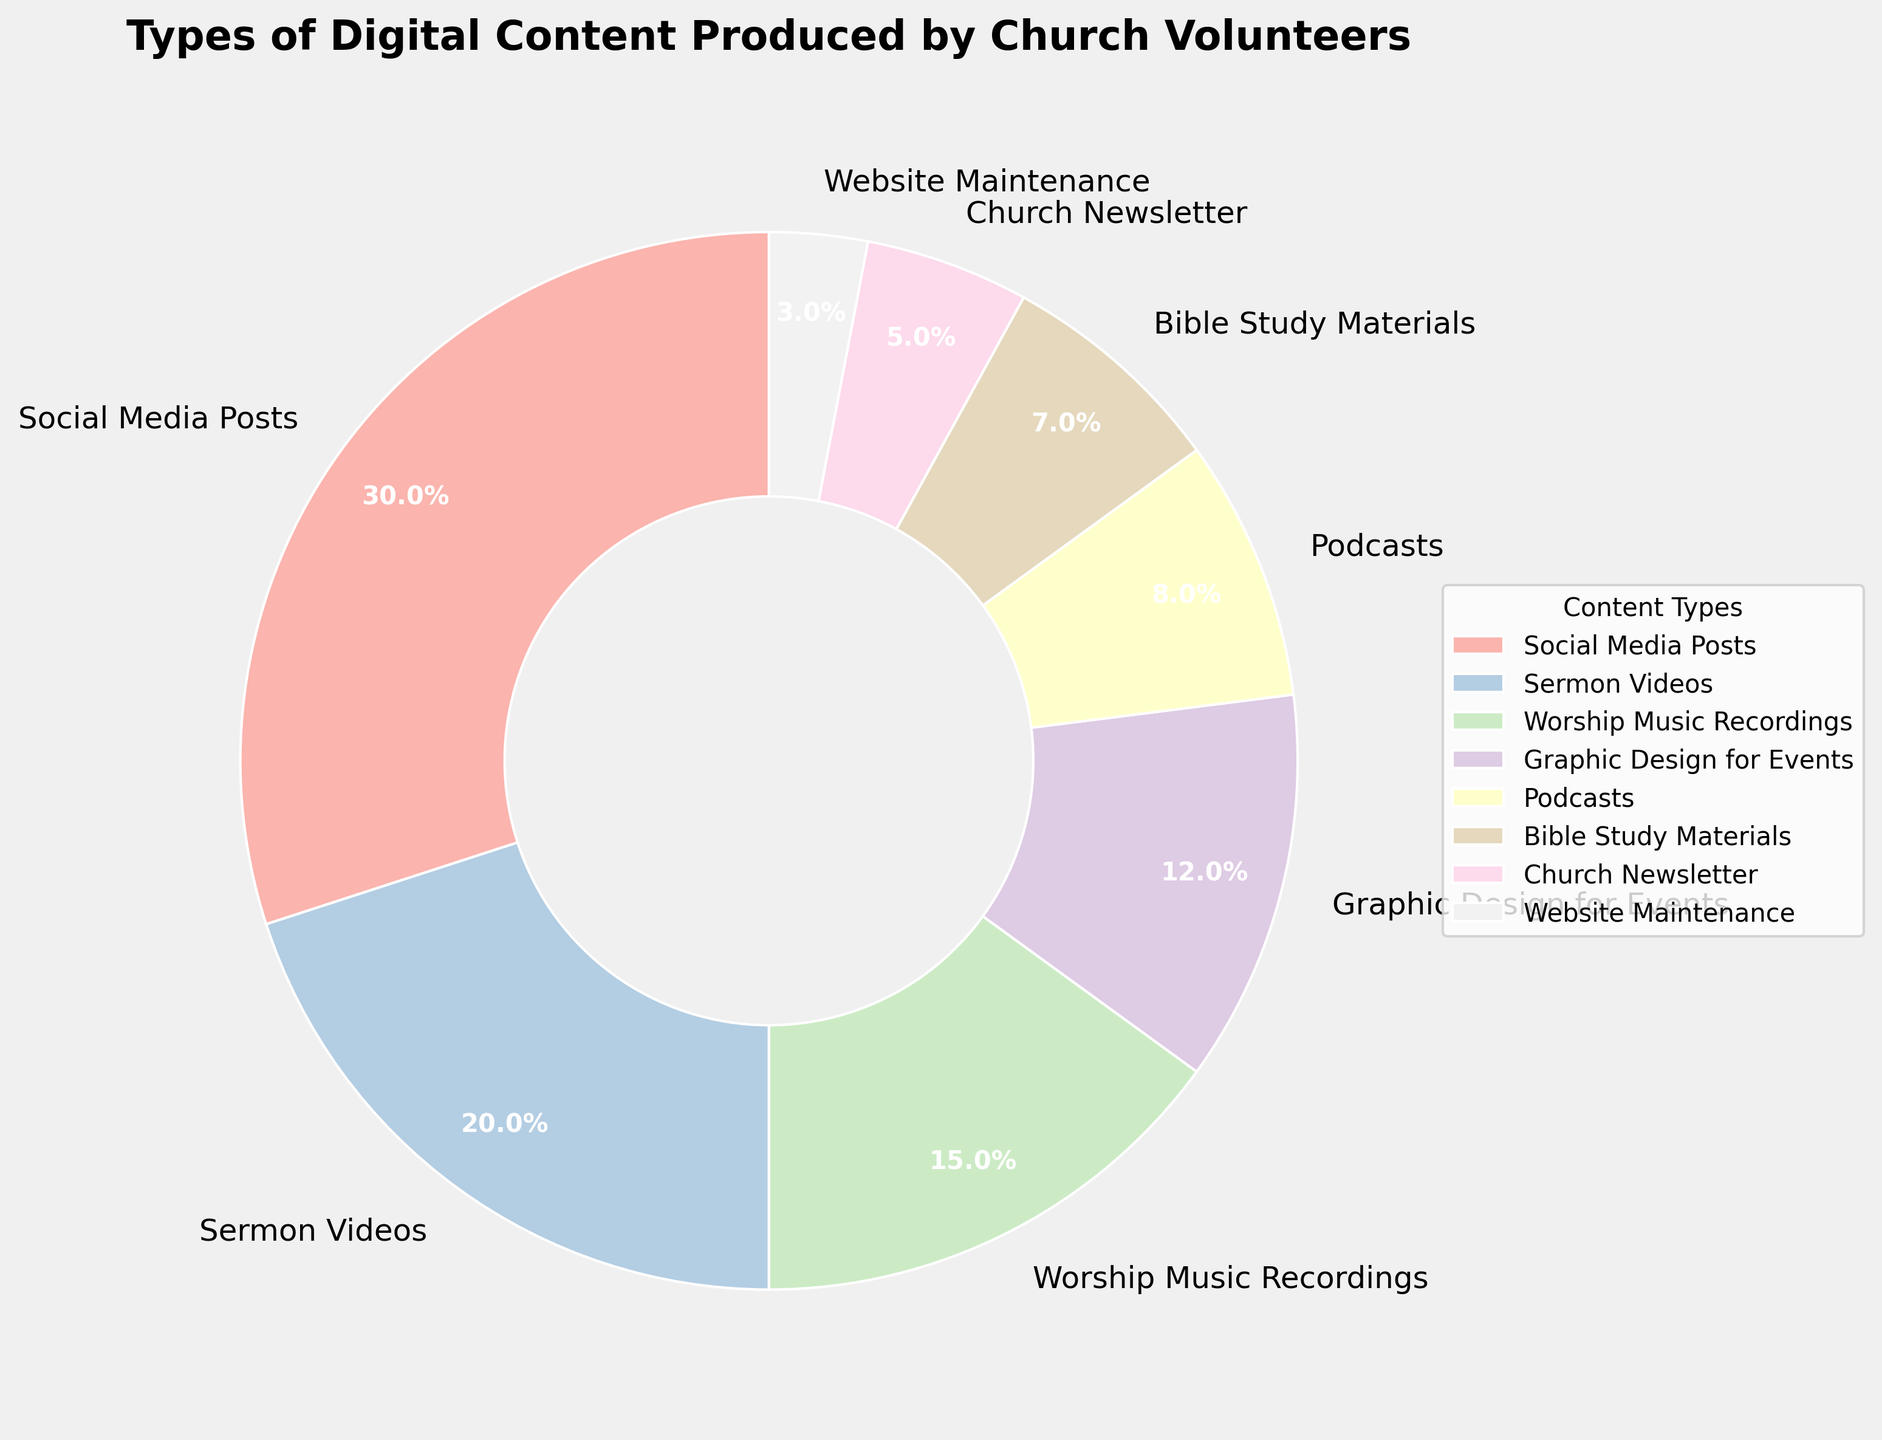Which type of digital content has the highest percentage of production? The pie chart shows different digital content types and their respective percentages. Social Media Posts has the highest percentage at 30%.
Answer: Social Media Posts What is the total percentage of content produced excluding Social Media Posts? Excluding Social Media Posts (30%), sum the percentages of the other content types: 20 (Sermon Videos) + 15 (Worship Music Recordings) + 12 (Graphic Design for Events) + 8 (Podcasts) + 7 (Bible Study Materials) + 5 (Church Newsletter) + 3 (Website Maintenance) = 70%.
Answer: 70% Which two content types combined have a percentage equal to that of Social Media Posts? Social Media Posts account for 30%. Combining Sermon Videos (20%) and Worship Music Recordings (15%) equals 35%, which is higher. However, combining 15% (Worship Music Recordings) and 12% (Graphic Design for Events) equals 27%, which is less. Therefore, no combination exactly equals 30%. Hence, using combinations like 20%+12%, 15%+12%, etc., 20%+12% (Sermon Videos + Graphic Design for Events) equals 32%, the closest.
Answer: Sermon Videos and Graphic Design for Events (32% is the closest) How does the percentage of Worship Music Recordings compare to that of Bible Study Materials? The pie chart shows Worship Music Recordings at 15% and Bible Study Materials at 7%. Comparing these, Worship Music Recordings have a higher percentage.
Answer: Worship Music Recordings is greater Which content type has the smallest percentage of production? The pie chart includes all content types and their percentages. Website Maintenance has the smallest percentage at 3%.
Answer: Website Maintenance What's the combined percentage of Sermon Videos, Worship Music Recordings, and Podcasts? Sum the percentages of 20% (Sermon Videos), 15% (Worship Music Recordings), and 8% (Podcasts): 20 + 15 + 8 = 43%.
Answer: 43% By how much does the percentage of Social Media Posts exceed that of Podcasts? Social Media Posts are 30%, and Podcasts are 8%. The difference is calculated by 30% - 8% = 22%.
Answer: 22% What is the difference in percentage points between the content type with the highest percentage and the content type with the lowest percentage? The highest percentage is for Social Media Posts (30%), and the lowest is for Website Maintenance (3%). The difference is 30% - 3% = 27 percentage points.
Answer: 27 percentage points 